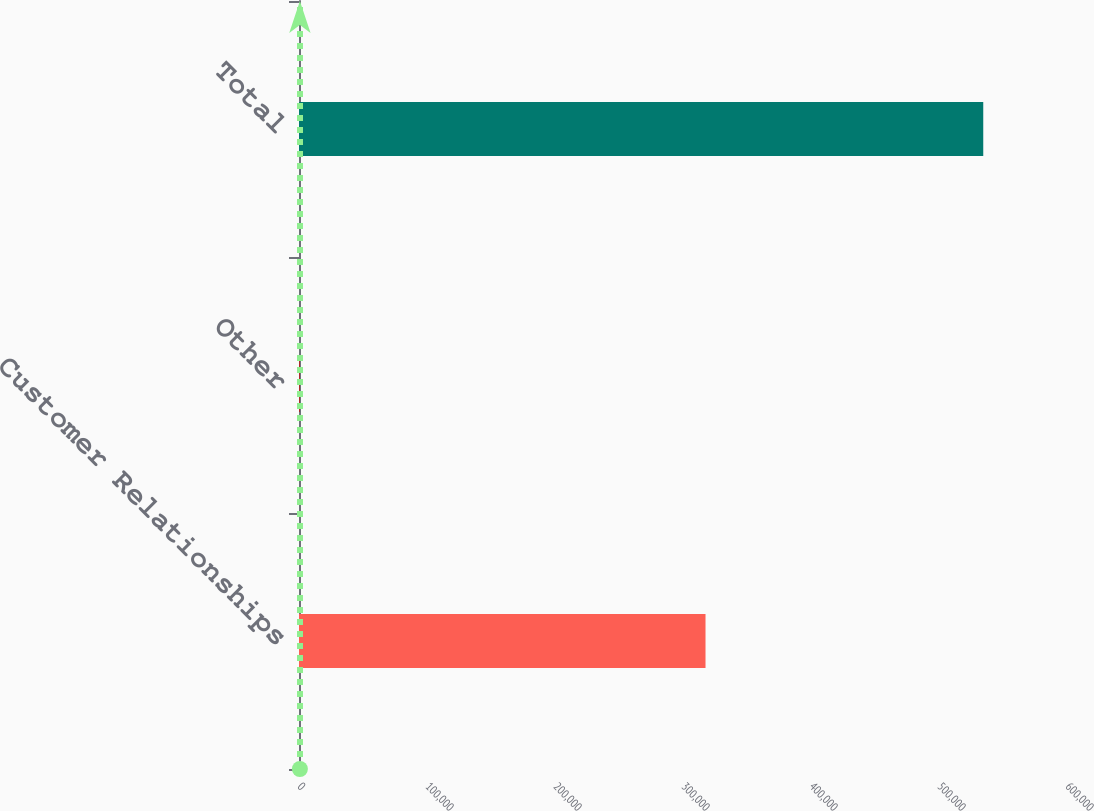Convert chart to OTSL. <chart><loc_0><loc_0><loc_500><loc_500><bar_chart><fcel>Customer Relationships<fcel>Other<fcel>Total<nl><fcel>317593<fcel>706<fcel>534572<nl></chart> 